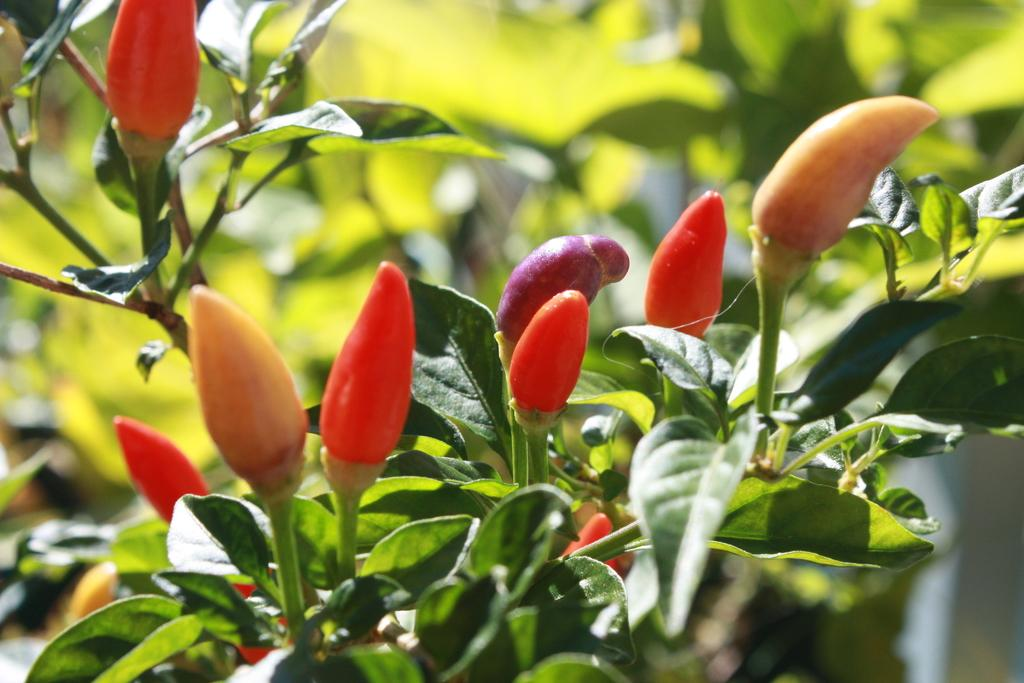What type of plant elements can be seen in the image? There are flower buds and leaves in the image. Can you describe the background of the image? The background of the image is blurry. What type of rhythm can be heard from the bell in the image? There is no bell present in the image, so there is no rhythm to be heard. What is the stick used for in the image? There is no stick present in the image, so it cannot be used for anything. 